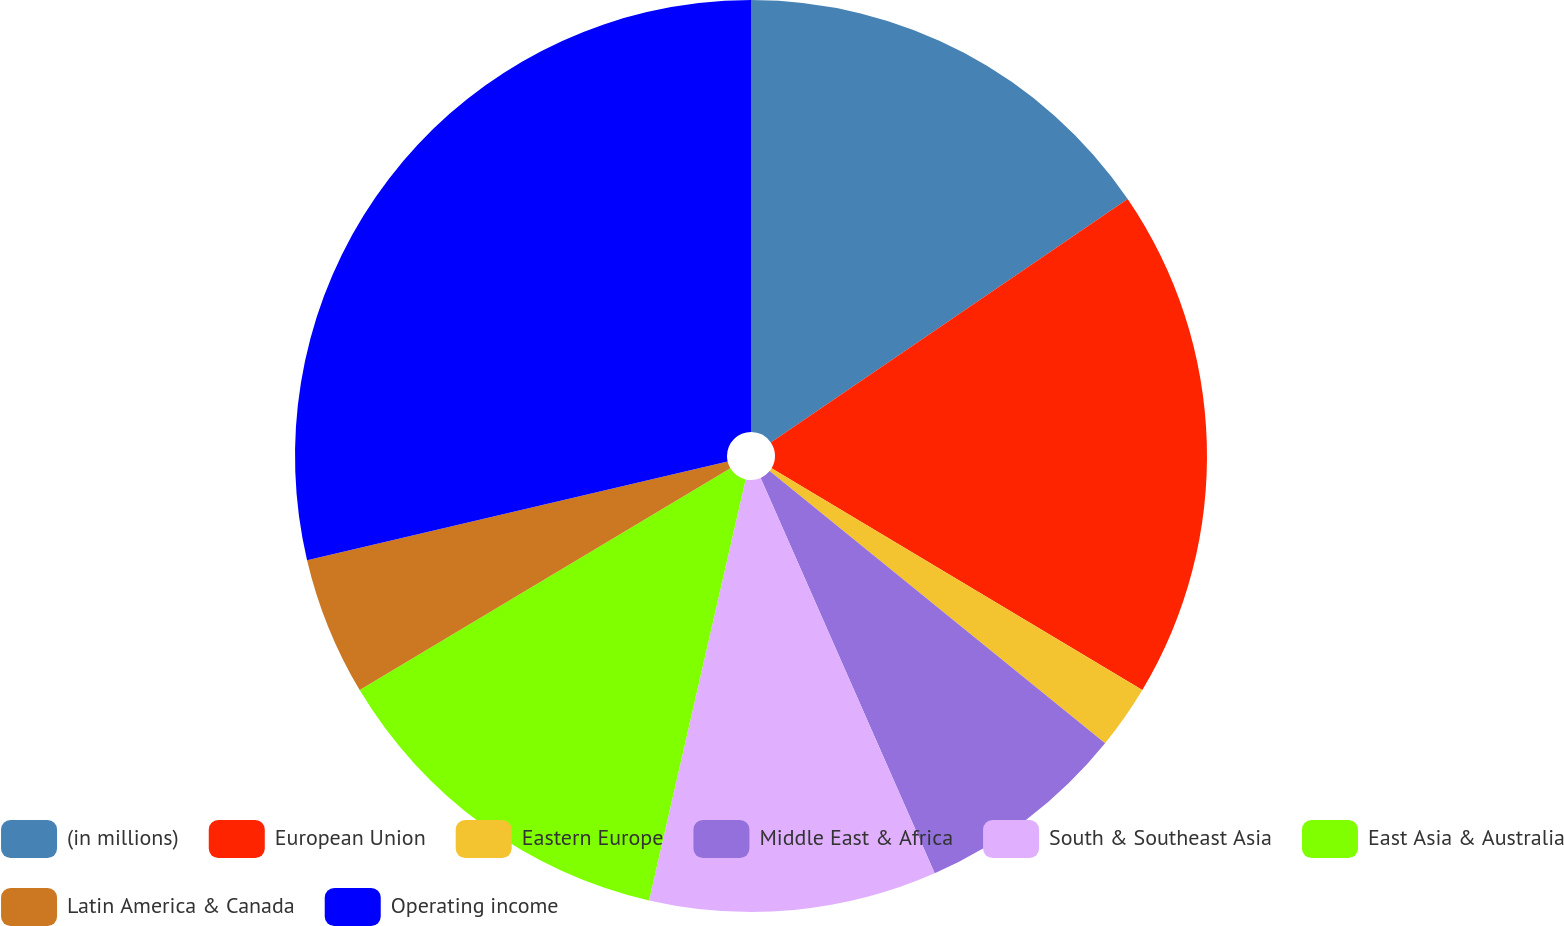Convert chart to OTSL. <chart><loc_0><loc_0><loc_500><loc_500><pie_chart><fcel>(in millions)<fcel>European Union<fcel>Eastern Europe<fcel>Middle East & Africa<fcel>South & Southeast Asia<fcel>East Asia & Australia<fcel>Latin America & Canada<fcel>Operating income<nl><fcel>15.47%<fcel>18.11%<fcel>2.27%<fcel>7.55%<fcel>10.19%<fcel>12.83%<fcel>4.91%<fcel>28.67%<nl></chart> 